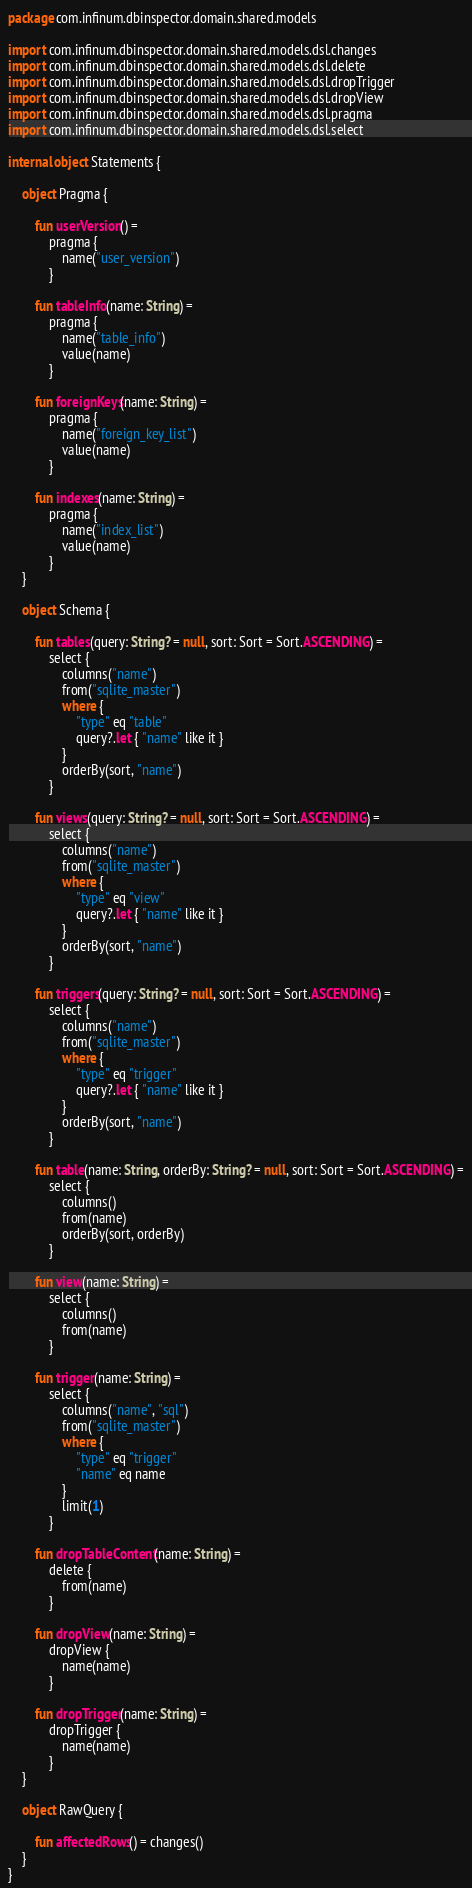Convert code to text. <code><loc_0><loc_0><loc_500><loc_500><_Kotlin_>package com.infinum.dbinspector.domain.shared.models

import com.infinum.dbinspector.domain.shared.models.dsl.changes
import com.infinum.dbinspector.domain.shared.models.dsl.delete
import com.infinum.dbinspector.domain.shared.models.dsl.dropTrigger
import com.infinum.dbinspector.domain.shared.models.dsl.dropView
import com.infinum.dbinspector.domain.shared.models.dsl.pragma
import com.infinum.dbinspector.domain.shared.models.dsl.select

internal object Statements {

    object Pragma {

        fun userVersion() =
            pragma {
                name("user_version")
            }

        fun tableInfo(name: String) =
            pragma {
                name("table_info")
                value(name)
            }

        fun foreignKeys(name: String) =
            pragma {
                name("foreign_key_list")
                value(name)
            }

        fun indexes(name: String) =
            pragma {
                name("index_list")
                value(name)
            }
    }

    object Schema {

        fun tables(query: String? = null, sort: Sort = Sort.ASCENDING) =
            select {
                columns("name")
                from("sqlite_master")
                where {
                    "type" eq "table"
                    query?.let { "name" like it }
                }
                orderBy(sort, "name")
            }

        fun views(query: String? = null, sort: Sort = Sort.ASCENDING) =
            select {
                columns("name")
                from("sqlite_master")
                where {
                    "type" eq "view"
                    query?.let { "name" like it }
                }
                orderBy(sort, "name")
            }

        fun triggers(query: String? = null, sort: Sort = Sort.ASCENDING) =
            select {
                columns("name")
                from("sqlite_master")
                where {
                    "type" eq "trigger"
                    query?.let { "name" like it }
                }
                orderBy(sort, "name")
            }

        fun table(name: String, orderBy: String? = null, sort: Sort = Sort.ASCENDING) =
            select {
                columns()
                from(name)
                orderBy(sort, orderBy)
            }

        fun view(name: String) =
            select {
                columns()
                from(name)
            }

        fun trigger(name: String) =
            select {
                columns("name", "sql")
                from("sqlite_master")
                where {
                    "type" eq "trigger"
                    "name" eq name
                }
                limit(1)
            }

        fun dropTableContent(name: String) =
            delete {
                from(name)
            }

        fun dropView(name: String) =
            dropView {
                name(name)
            }

        fun dropTrigger(name: String) =
            dropTrigger {
                name(name)
            }
    }

    object RawQuery {

        fun affectedRows() = changes()
    }
}
</code> 